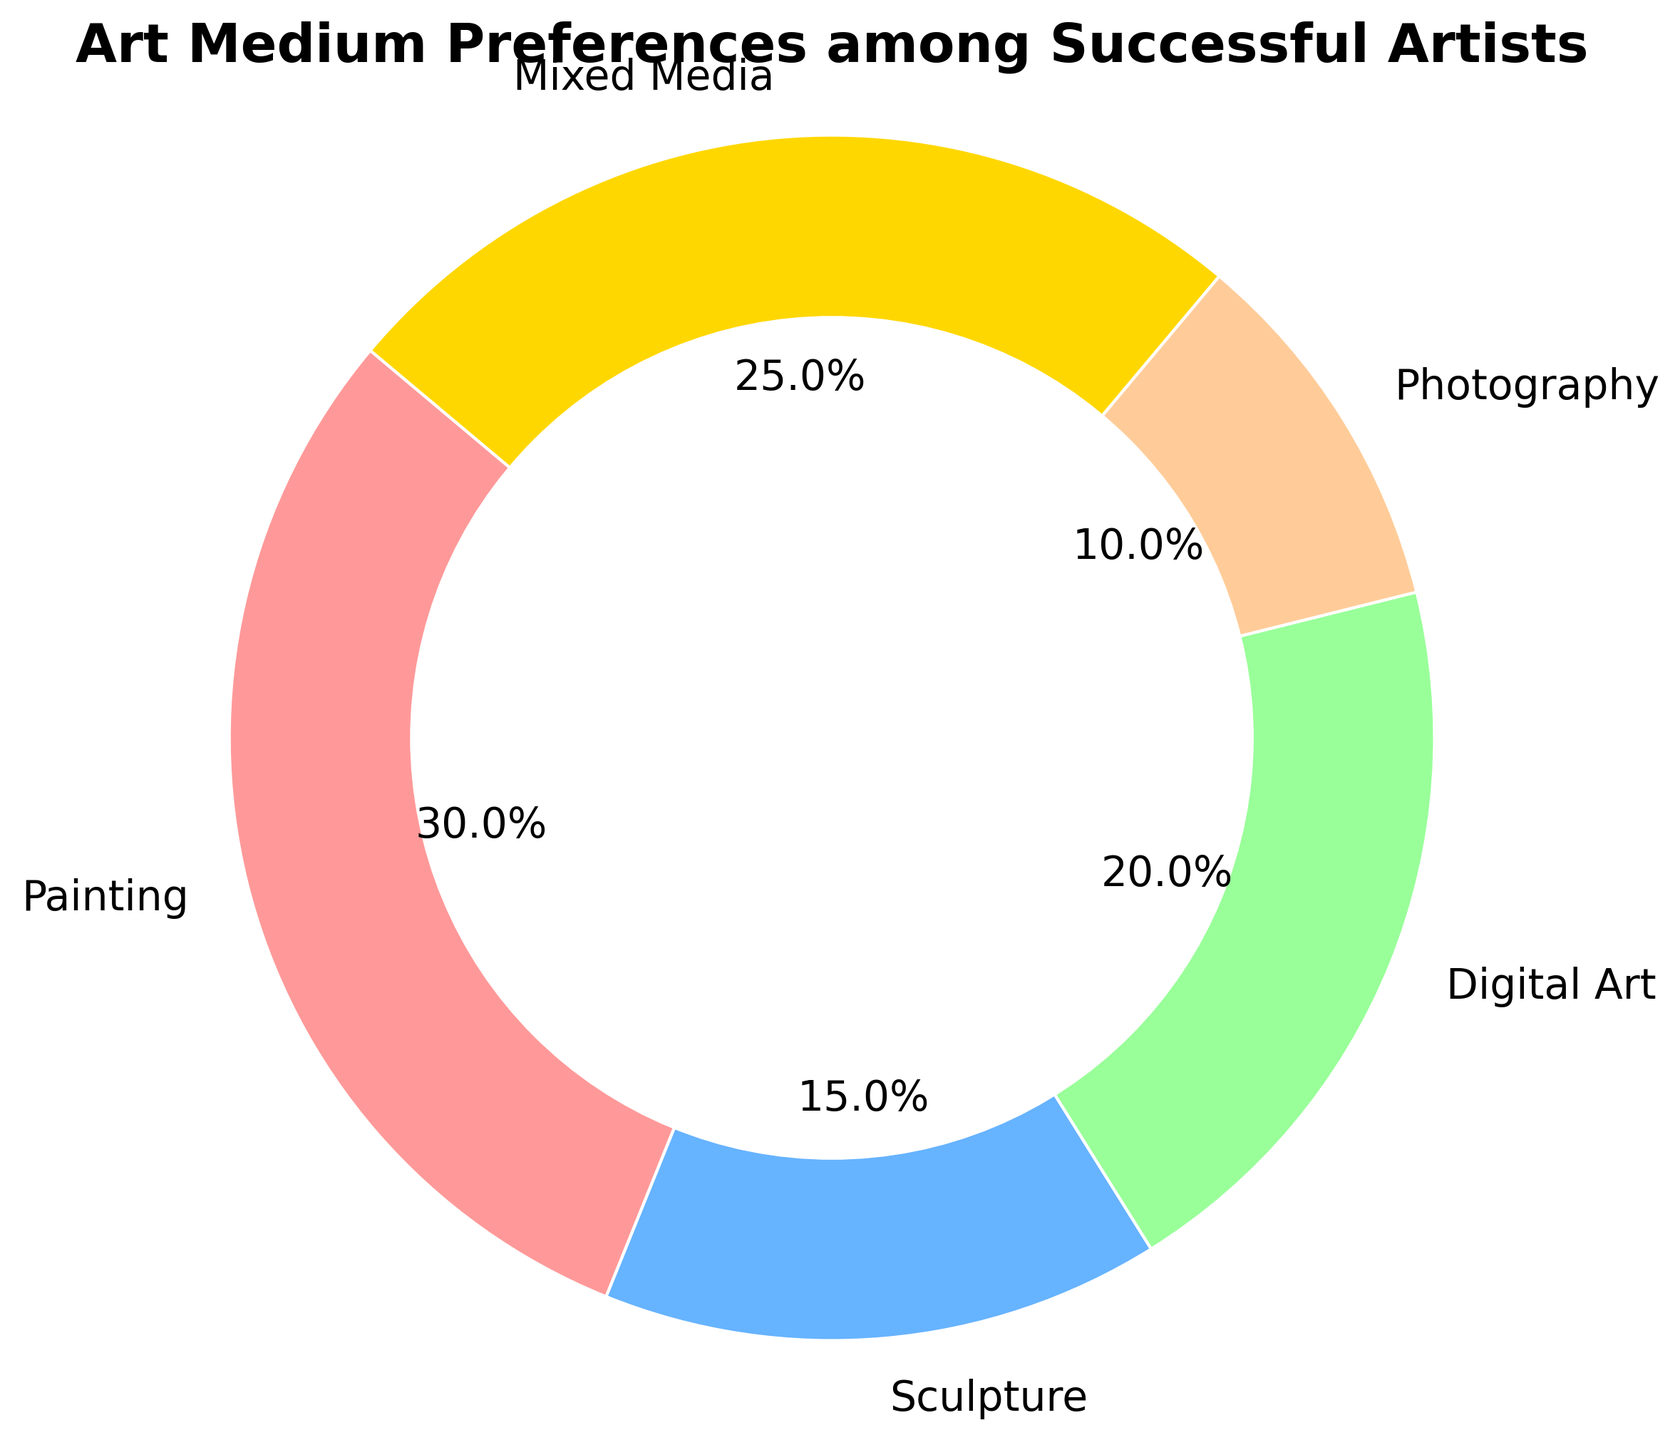What is the most preferred art medium among successful artists? The pie chart shows the preference of different art mediums among successful artists. From the chart, we see that Painting has the largest slice.
Answer: Painting Which art medium has the smallest share among successful artists? The pie chart segments vary in size, and the smallest segment represents Photography.
Answer: Photography What percentage of successful artists prefer Digital Art? The pie chart includes labels that display percentages. The label for Digital Art shows 20%.
Answer: 20% How much larger is the preference for Mixed Media compared to Sculpture among successful artists? According to the chart, Mixed Media is 25% and Sculpture is 15%. The difference can be calculated as 25% - 15%.
Answer: 10% What is the combined percentage of successful artists who prefer Painting and Digital Art? We sum up the percentages for Painting and Digital Art: 30% + 20% = 50%.
Answer: 50% Which two art mediums account for half of all preferences among successful artists? The goal is to find a combination of two segments that add up to 50%. Painting and Digital Art together form 50% as 30% + 20% equals 50%.
Answer: Painting and Digital Art How much greater is the preference for Painting compared to Photography among successful artists? The preference for Painting is 30% and for Photography is 10%. The difference is 30% - 10%.
Answer: 20% What is the sum of the preferences for Sculpture, Digital Art, and Mixed Media among successful artists? Adding the percentages for Sculpture (15%), Digital Art (20%), and Mixed Media (25%) gives 15% + 20% + 25% = 60%.
Answer: 60% Which color represents Mixed Media in the pie chart? The wedge corresponding to Mixed Media has a distinctive golden hue among the colors displayed.
Answer: Golden Do more than half of the successful artists prefer Mixed Media or Painting? Together, the percentages for Mixed Media and Painting are 25% + 30%, which equals 55%, exceeding 50%.
Answer: Yes 